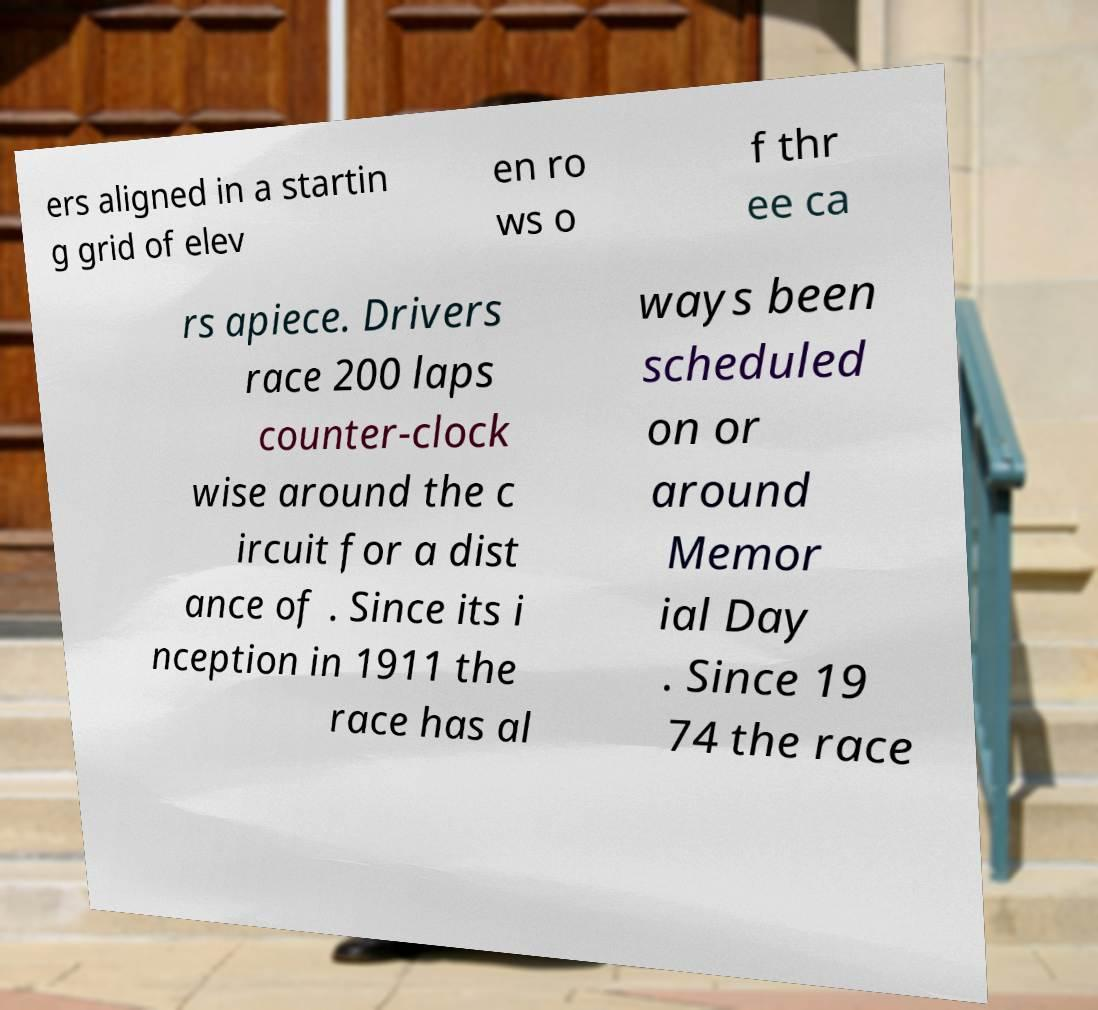Please read and relay the text visible in this image. What does it say? ers aligned in a startin g grid of elev en ro ws o f thr ee ca rs apiece. Drivers race 200 laps counter-clock wise around the c ircuit for a dist ance of . Since its i nception in 1911 the race has al ways been scheduled on or around Memor ial Day . Since 19 74 the race 